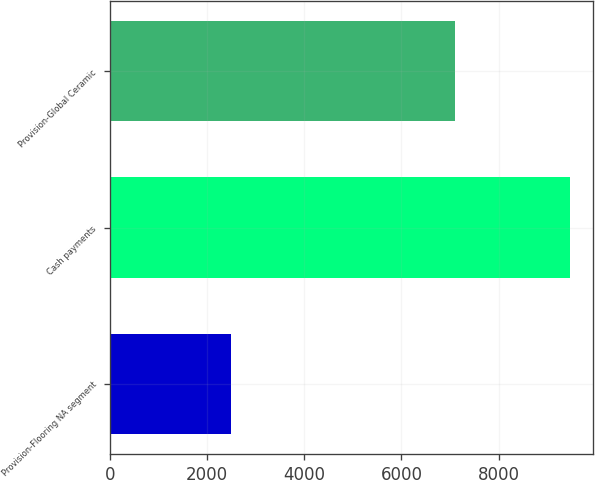Convert chart. <chart><loc_0><loc_0><loc_500><loc_500><bar_chart><fcel>Provision-Flooring NA segment<fcel>Cash payments<fcel>Provision-Global Ceramic<nl><fcel>2500<fcel>9469<fcel>7113<nl></chart> 